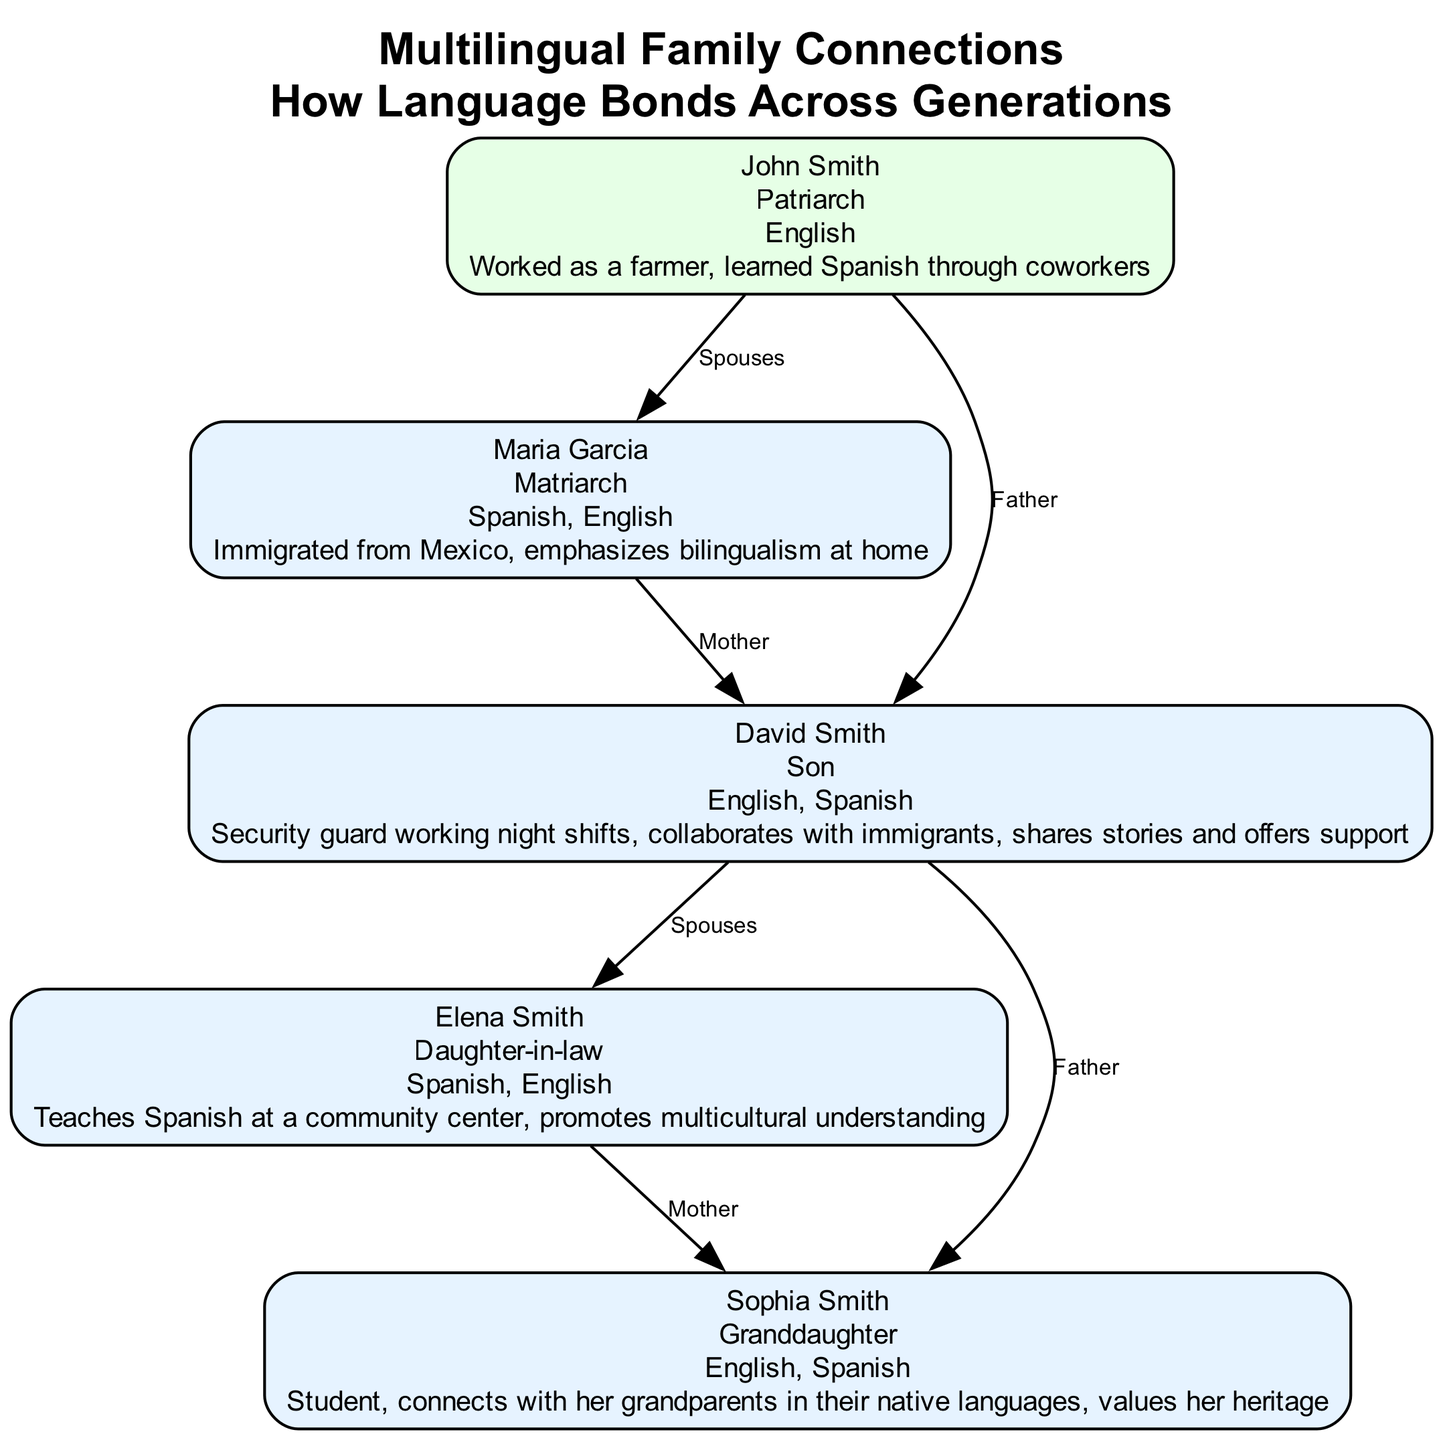What is the relationship between John Smith and Maria Garcia? The diagram shows an edge connecting John Smith to Maria Garcia labeled "Spouses," indicating they are married to each other.
Answer: Spouses How many languages does Sophia Smith speak? By reviewing the node for Sophia Smith, it lists "English, Spanish" under languages spoken, confirming she speaks two languages.
Answer: 2 Who is the patriarch of the family? The title "Patriarch" is designated to John Smith in the diagram, identifying him as the male head of the family.
Answer: John Smith What language does David Smith primarily use at work and in collaboration? David Smith's node mentions he is a security guard who collaborates with immigrants and shares stories, indicating he uses both "English" and "Spanish" due to his bilingual background.
Answer: English, Spanish How many children does David Smith have? By looking at the connections originating from David Smith, there is one connection to Elena Smith (spouse) and one connection to Sophia Smith (daughter), indicating he has one child.
Answer: 1 Which family member emphasizes bilingualism? The node for Maria Garcia shows she emphasizes bilingualism at home, as she is an immigrant from Mexico and speaks both Spanish and English.
Answer: Maria Garcia What occupation does Elena Smith hold? The story in Elena Smith's node states she teaches Spanish at a community center, revealing her occupation focused on education and cultural promotion.
Answer: Teacher What language connects all generations in the family tree? The languages spoken by all the family members include "Spanish" as a common language across generations, binding them culturally and linguistically.
Answer: Spanish How does Sophia Smith connect with her grandparents? Sophia Smith's node describes her as valuing her heritage and connecting with her grandparents in their native languages, demonstrating intergenerational communication.
Answer: Native languages What is the relationship between David Smith and Sophia Smith? The diagram indicates a direct relationship labeled "Father" from David Smith to Sophia Smith, identifying him as her dad.
Answer: Father 